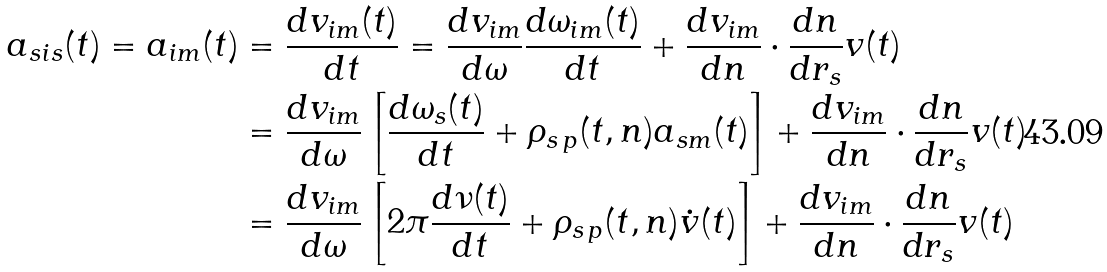Convert formula to latex. <formula><loc_0><loc_0><loc_500><loc_500>a _ { s i s } ( t ) = a _ { i m } ( t ) & = \frac { d v _ { i m } ( t ) } { d t } = \frac { d v _ { i m } } { d \omega } \frac { d \omega _ { i m } ( t ) } { d t } + \frac { d v _ { i m } } { d n } \cdot \frac { d n } { d r _ { s } } v ( t ) \\ & = \frac { d v _ { i m } } { d \omega } \left [ \frac { d \omega _ { s } ( t ) } { d t } + \rho _ { s \, p } ( t , n ) a _ { s m } ( t ) \right ] + \frac { d v _ { i m } } { d n } \cdot \frac { d n } { d r _ { s } } v ( t ) \\ & = \frac { d v _ { i m } } { d \omega } \left [ 2 \pi \frac { d \nu ( t ) } { d t } + \rho _ { s \, p } ( t , n ) \dot { v } ( t ) \right ] + \frac { d v _ { i m } } { d n } \cdot \frac { d n } { d r _ { s } } v ( t )</formula> 